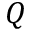<formula> <loc_0><loc_0><loc_500><loc_500>Q</formula> 